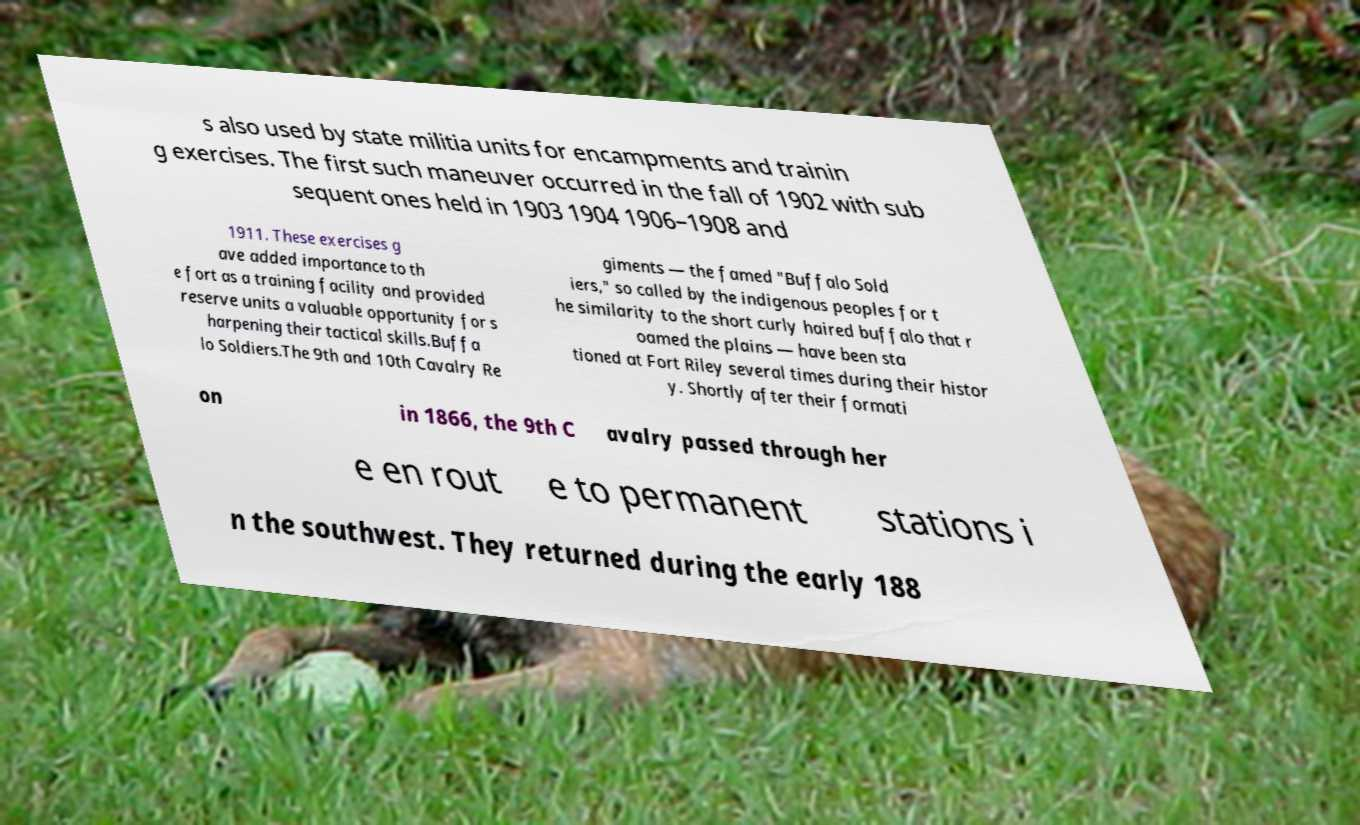Could you extract and type out the text from this image? s also used by state militia units for encampments and trainin g exercises. The first such maneuver occurred in the fall of 1902 with sub sequent ones held in 1903 1904 1906–1908 and 1911. These exercises g ave added importance to th e fort as a training facility and provided reserve units a valuable opportunity for s harpening their tactical skills.Buffa lo Soldiers.The 9th and 10th Cavalry Re giments — the famed "Buffalo Sold iers," so called by the indigenous peoples for t he similarity to the short curly haired buffalo that r oamed the plains — have been sta tioned at Fort Riley several times during their histor y. Shortly after their formati on in 1866, the 9th C avalry passed through her e en rout e to permanent stations i n the southwest. They returned during the early 188 